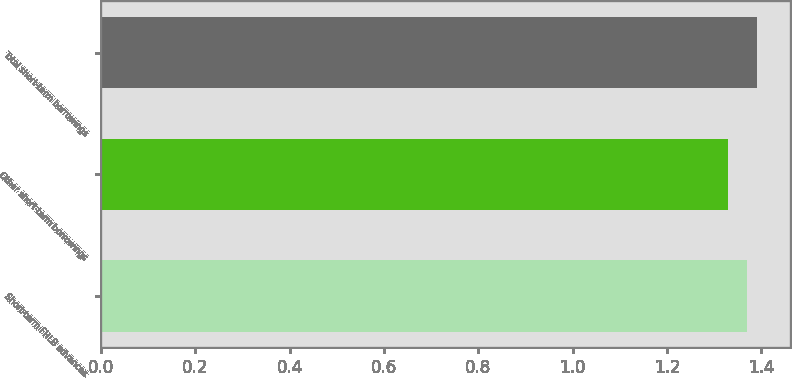Convert chart to OTSL. <chart><loc_0><loc_0><loc_500><loc_500><bar_chart><fcel>Short-term FHLB advances<fcel>Other short-term borrowings<fcel>Total short-term borrowings<nl><fcel>1.37<fcel>1.33<fcel>1.39<nl></chart> 